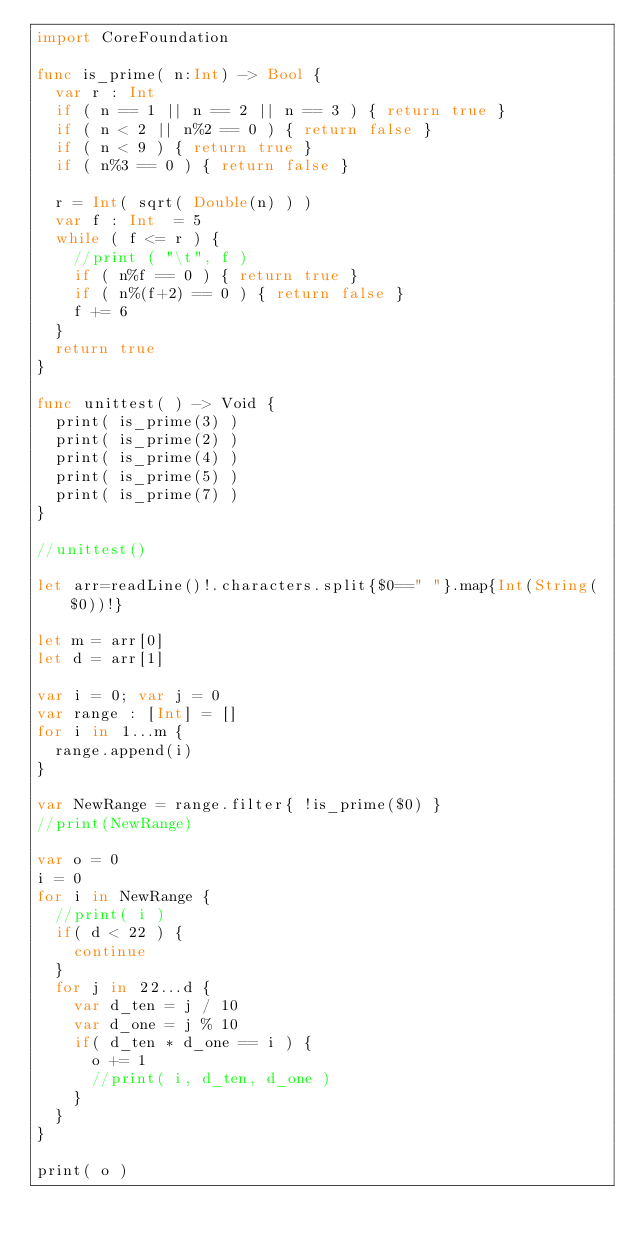<code> <loc_0><loc_0><loc_500><loc_500><_Swift_>import CoreFoundation

func is_prime( n:Int) -> Bool {
  var r : Int
  if ( n == 1 || n == 2 || n == 3 ) { return true }
  if ( n < 2 || n%2 == 0 ) { return false }
  if ( n < 9 ) { return true }
  if ( n%3 == 0 ) { return false }

  r = Int( sqrt( Double(n) ) )
  var f : Int  = 5
  while ( f <= r ) {
    //print ( "\t", f )
    if ( n%f == 0 ) { return true }
    if ( n%(f+2) == 0 ) { return false }
    f += 6
  }
  return true
}

func unittest( ) -> Void {
  print( is_prime(3) )
  print( is_prime(2) )
  print( is_prime(4) )
  print( is_prime(5) )
  print( is_prime(7) )
}

//unittest()

let arr=readLine()!.characters.split{$0==" "}.map{Int(String($0))!}

let m = arr[0]
let d = arr[1]

var i = 0; var j = 0
var range : [Int] = []
for i in 1...m {
	range.append(i)
}

var NewRange = range.filter{ !is_prime($0) } 
//print(NewRange)

var o = 0
i = 0
for i in NewRange {
  //print( i )
  if( d < 22 ) {
    continue
  }
  for j in 22...d {
    var d_ten = j / 10
    var d_one = j % 10
    if( d_ten * d_one == i ) {
      o += 1
      //print( i, d_ten, d_one )
    }
  }
}

print( o )</code> 